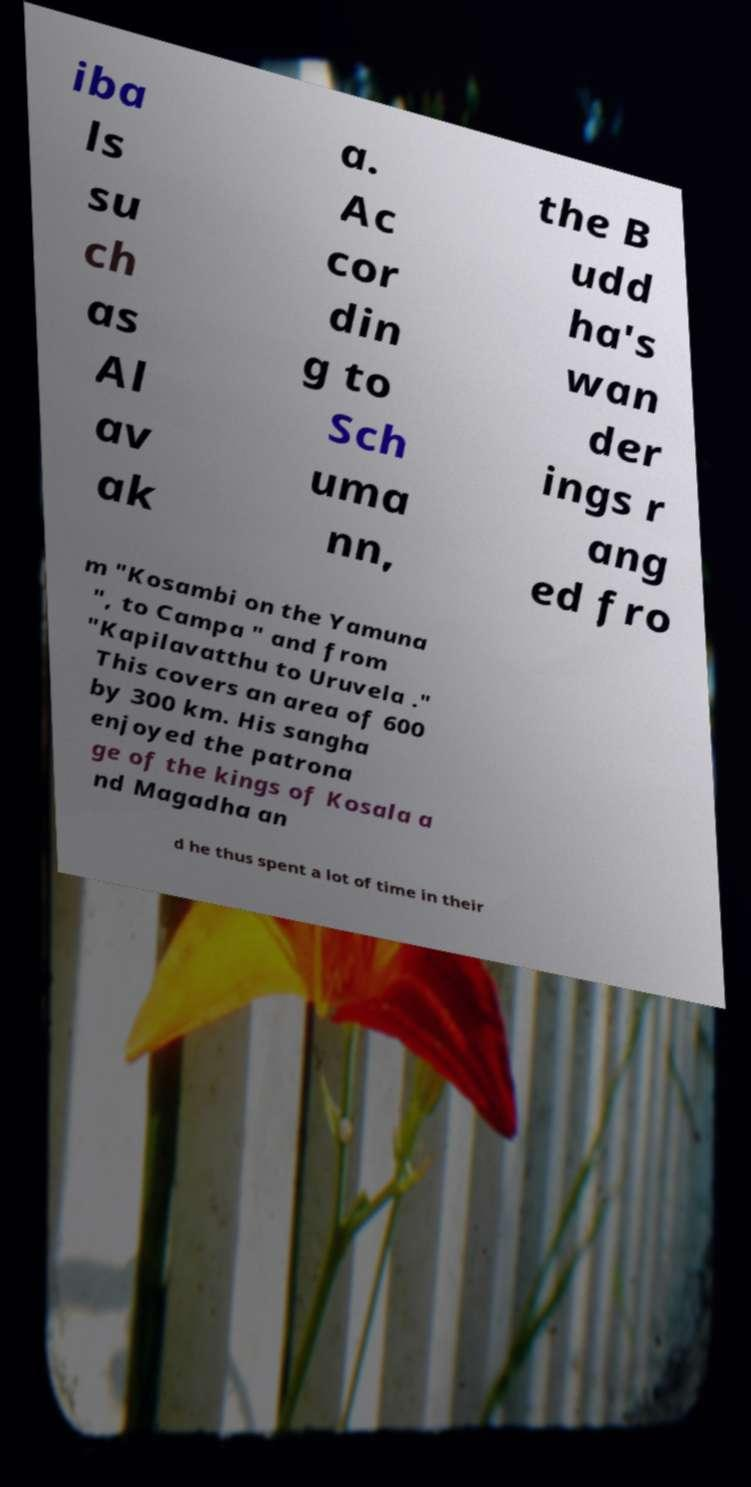For documentation purposes, I need the text within this image transcribed. Could you provide that? iba ls su ch as Al av ak a. Ac cor din g to Sch uma nn, the B udd ha's wan der ings r ang ed fro m "Kosambi on the Yamuna ", to Campa " and from "Kapilavatthu to Uruvela ." This covers an area of 600 by 300 km. His sangha enjoyed the patrona ge of the kings of Kosala a nd Magadha an d he thus spent a lot of time in their 